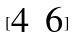<formula> <loc_0><loc_0><loc_500><loc_500>[ \begin{matrix} 4 & 6 \end{matrix} ]</formula> 